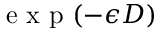Convert formula to latex. <formula><loc_0><loc_0><loc_500><loc_500>e x p ( - \epsilon D )</formula> 